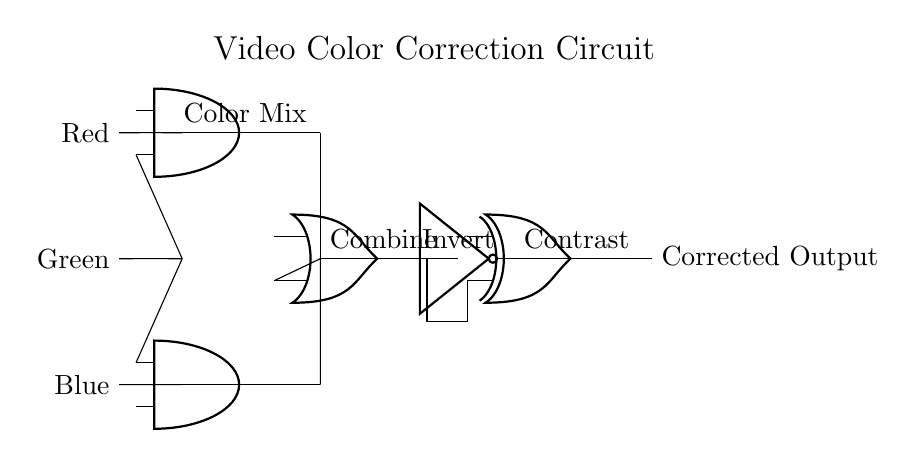What are the input signals to the circuit? The circuit inputs are Red, Green, and Blue signals, clearly marked on the left side of the diagram.
Answer: Red, Green, Blue What type of gate is used to combine the Red and Green signals? The circuit uses an AND gate for combining the Red and Green signals, as indicated near the AND port labeled "Color Mix."
Answer: AND gate How many logic gates are present in this circuit? The circuit diagram shows four logic gates: two AND gates, one OR gate, one NOT gate, and one XOR gate.
Answer: Five gates What is the purpose of the NOT gate in this circuit? The NOT gate inverts the output from the OR gate, which is an essential step for enhancing video color correction by adjusting the signals' polarity.
Answer: Invert What is the final output of the circuit after processing the input signals? The final output of the circuit is labeled as "Corrected Output," representing the result after all processing steps.
Answer: Corrected Output How does the output of the OR gate connect to the XOR gate? The output of the OR gate is directly connected to the XOR gate along the same horizontal line, allowing it to influence the contrast adjustment process.
Answer: Directly connected Can you identify the sequence of operations performed by the gates? The sequence involves mixing colors with AND gates, combining with OR, inverting with NOT, and finally adjusting contrast with XOR, which flow from inputs to the output.
Answer: AND, OR, NOT, XOR 